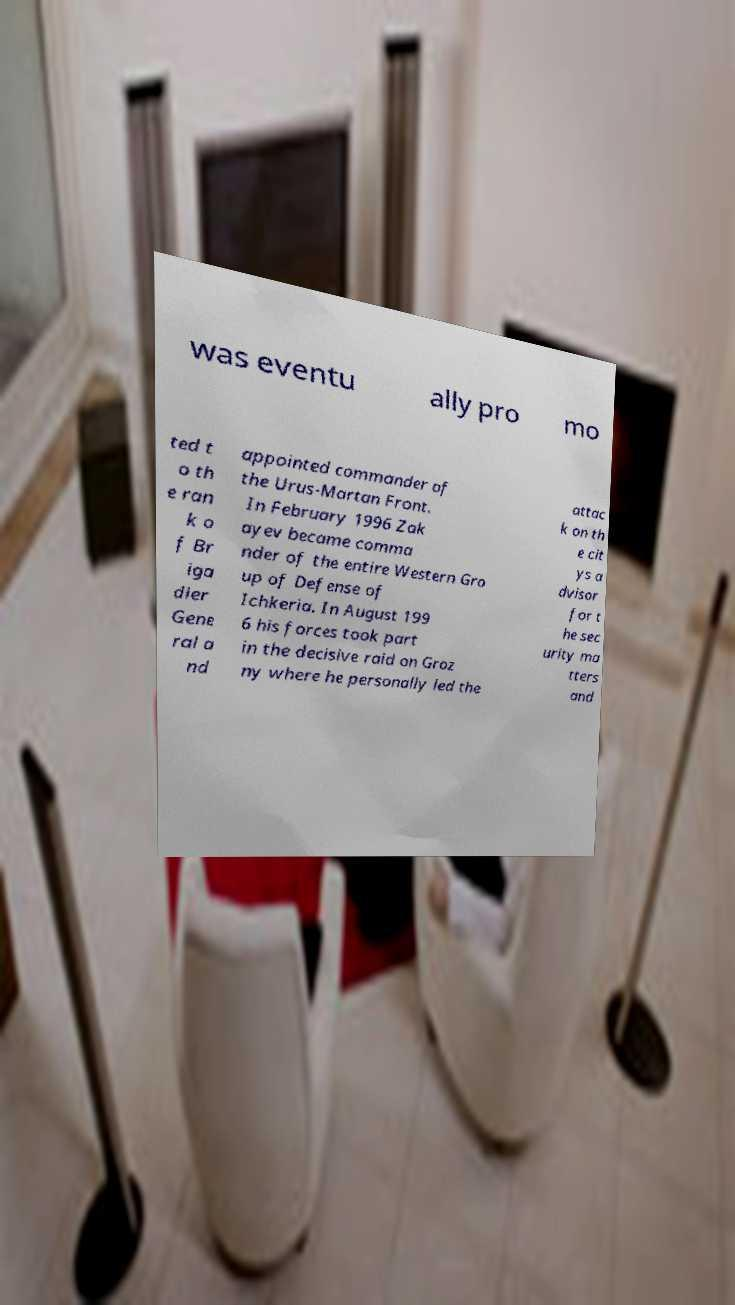What messages or text are displayed in this image? I need them in a readable, typed format. was eventu ally pro mo ted t o th e ran k o f Br iga dier Gene ral a nd appointed commander of the Urus-Martan Front. In February 1996 Zak ayev became comma nder of the entire Western Gro up of Defense of Ichkeria. In August 199 6 his forces took part in the decisive raid on Groz ny where he personally led the attac k on th e cit ys a dvisor for t he sec urity ma tters and 